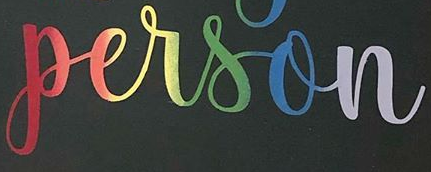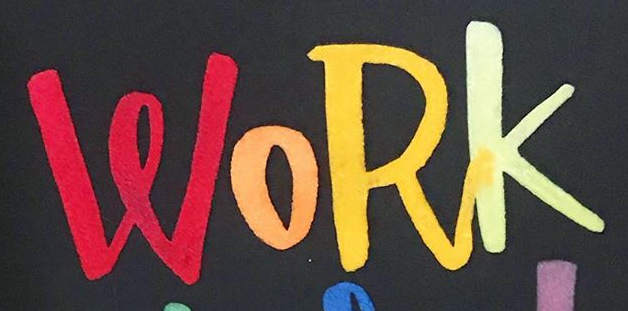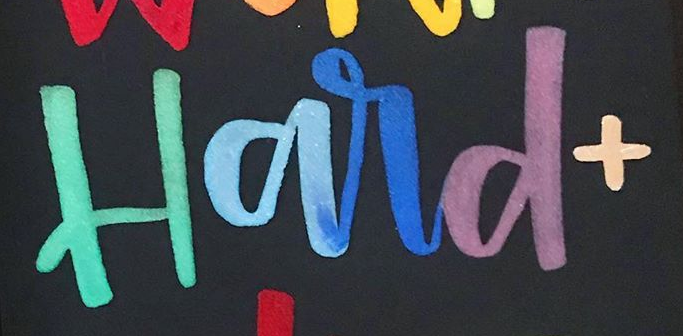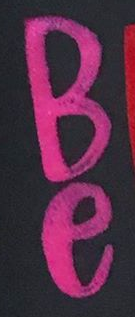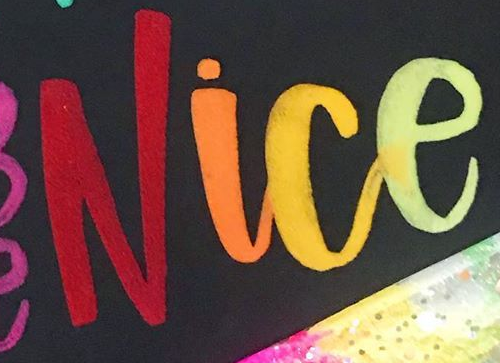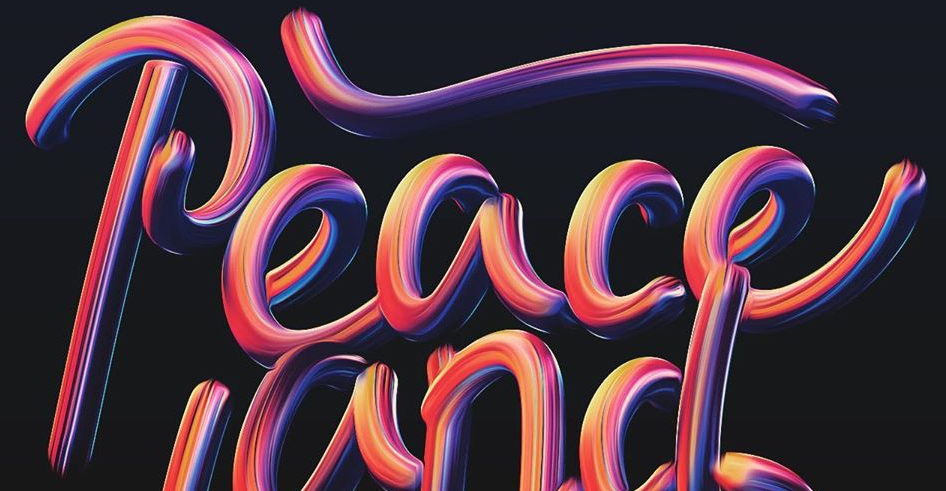What text is displayed in these images sequentially, separated by a semicolon? person; WORK; Hard+; Be; Nice; Peace 